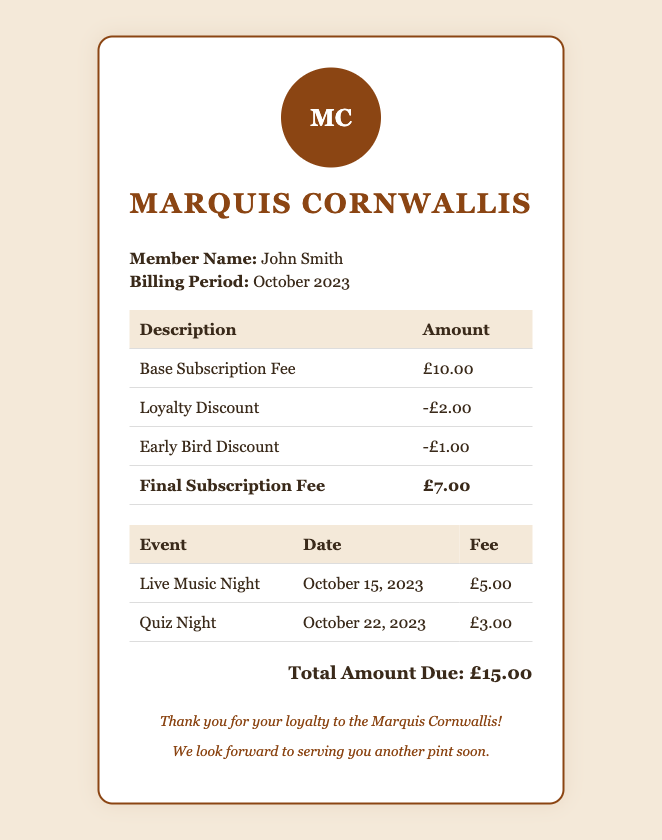What is the member's name? The member's name is displayed in the bill under the member information section.
Answer: John Smith What is the billing period for this bill? The billing period is indicated next to the member's name in the document.
Answer: October 2023 What is the base subscription fee? The base subscription fee is listed in the table detailing subscription fees.
Answer: £10.00 What discount was provided for loyalty? The loyalty discount amount is shown in the discounts section of the bill.
Answer: -£2.00 What is the final subscription fee after discounts? The final subscription fee is indicated as the total after applying discounts from the base fee.
Answer: £7.00 How much does the Live Music Night cost? The cost for the Live Music Night is found in the event fee table.
Answer: £5.00 How many events are listed in the bill? The number of events can be determined by counting the entries in the event table.
Answer: 2 What is the total amount due? The total amount due is summarized at the bottom of the bill.
Answer: £15.00 What is the date of the Quiz Night? The date for the Quiz Night is provided in the event details section.
Answer: October 22, 2023 